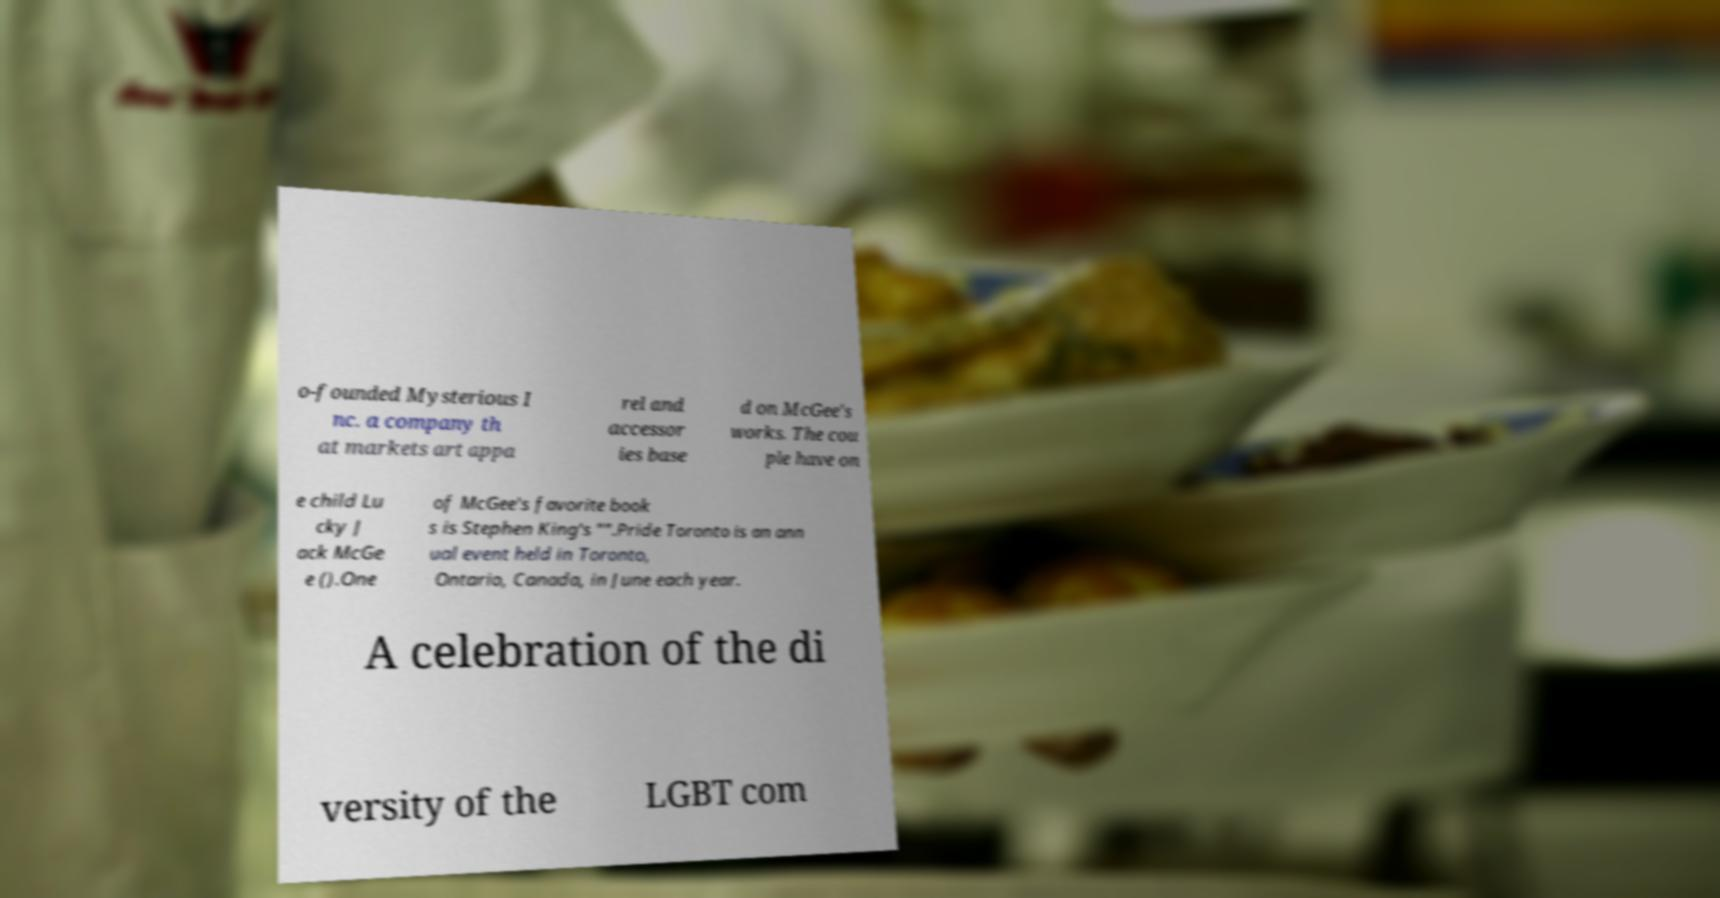For documentation purposes, I need the text within this image transcribed. Could you provide that? o-founded Mysterious I nc. a company th at markets art appa rel and accessor ies base d on McGee's works. The cou ple have on e child Lu cky J ack McGe e ().One of McGee's favorite book s is Stephen King's "".Pride Toronto is an ann ual event held in Toronto, Ontario, Canada, in June each year. A celebration of the di versity of the LGBT com 